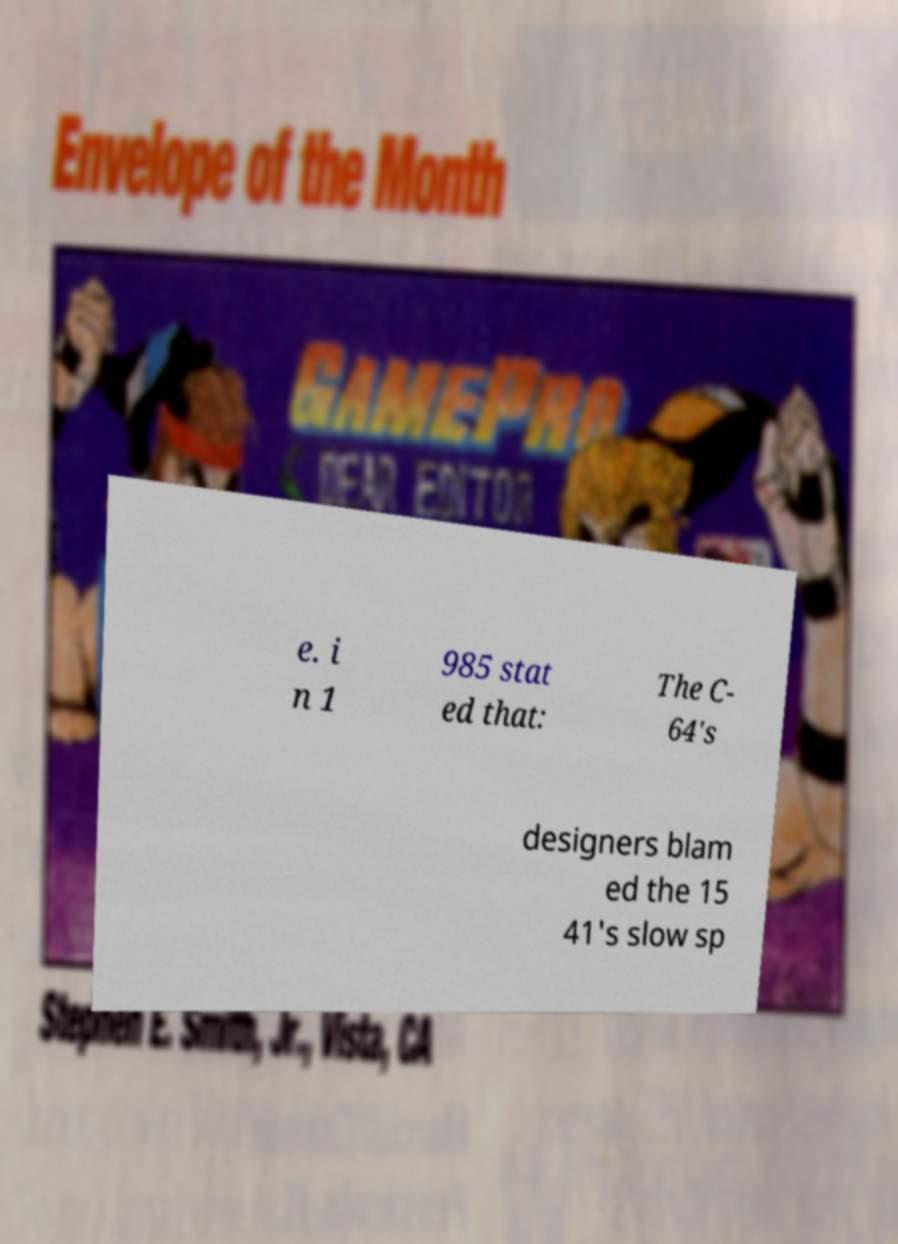Could you extract and type out the text from this image? e. i n 1 985 stat ed that: The C- 64's designers blam ed the 15 41's slow sp 